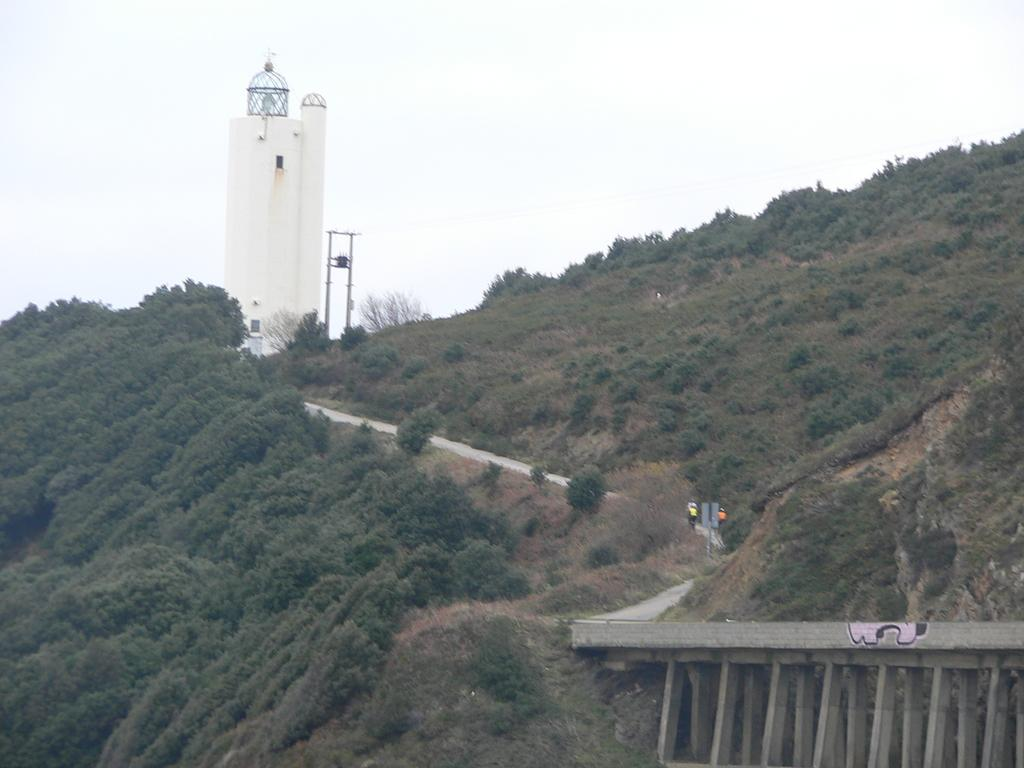What is the main structure in the center of the image? There is a tower in the center of the image. What type of natural elements can be seen in the image? There are trees in the image. What type of man-made structure is present in the image? There is a road and a bridge in the image. What type of straw is being used to build the tower in the image? There is no straw present in the image; the tower appears to be made of a different material. 